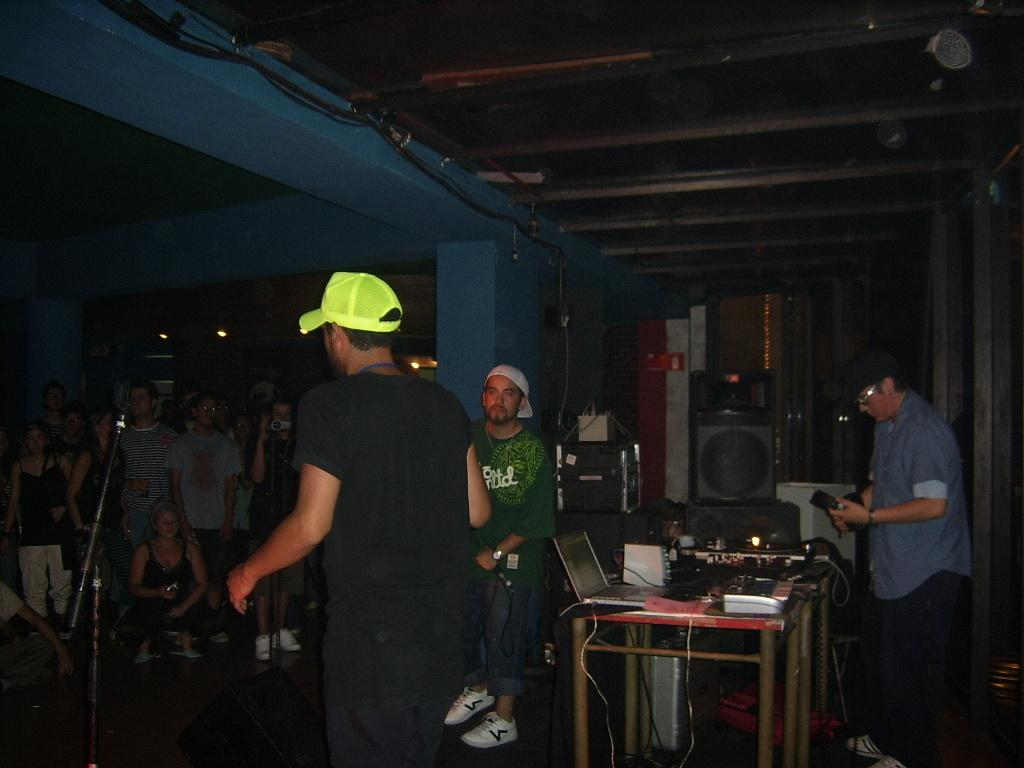Who is the main subject in the image? There is a man in the image. What is the man wearing on his head? The man is wearing a yellow cap. What is the man doing in the image? The man is speaking to a group of people. Where are the people in relation to the man? The group of people is in front of the man. What type of cat can be seen sitting next to the scarecrow in the image? There is no cat or scarecrow present in the image; it features a man speaking to a group of people. What color are the teeth of the man in the image? The image does not show the man's teeth, so it cannot be determined what color they are. 